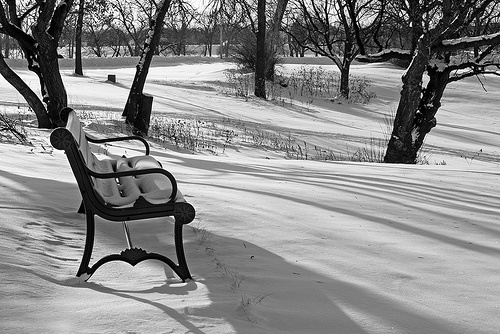Describe the objects in this image and their specific colors. I can see a bench in gray, black, dimgray, darkgray, and lightgray tones in this image. 